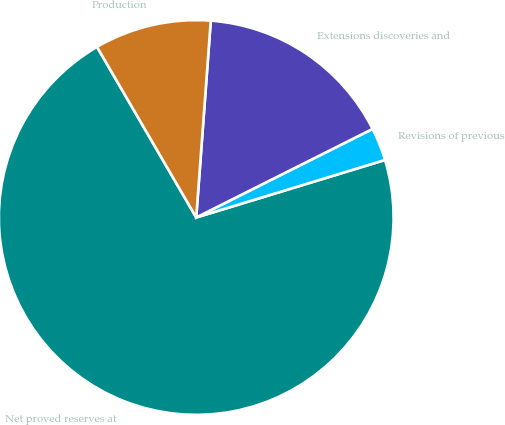<chart> <loc_0><loc_0><loc_500><loc_500><pie_chart><fcel>Net proved reserves at<fcel>Revisions of previous<fcel>Extensions discoveries and<fcel>Production<nl><fcel>71.32%<fcel>2.7%<fcel>16.42%<fcel>9.56%<nl></chart> 